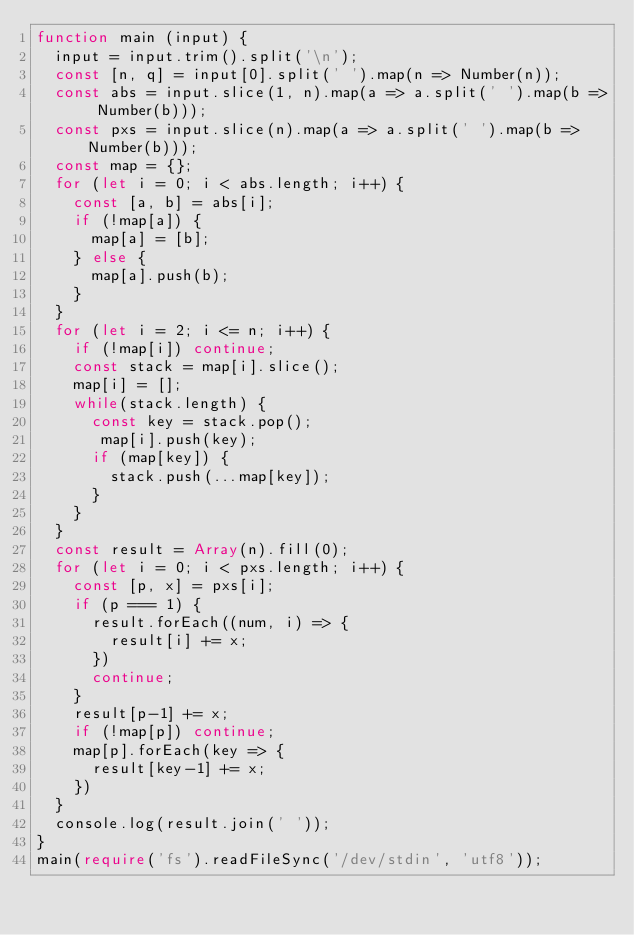Convert code to text. <code><loc_0><loc_0><loc_500><loc_500><_TypeScript_>function main (input) {
  input = input.trim().split('\n');
  const [n, q] = input[0].split(' ').map(n => Number(n));
  const abs = input.slice(1, n).map(a => a.split(' ').map(b => Number(b)));
  const pxs = input.slice(n).map(a => a.split(' ').map(b => Number(b)));
  const map = {};
  for (let i = 0; i < abs.length; i++) {
    const [a, b] = abs[i];
    if (!map[a]) {
      map[a] = [b];
    } else {
      map[a].push(b);
    }
  }
  for (let i = 2; i <= n; i++) {
    if (!map[i]) continue;
    const stack = map[i].slice();
    map[i] = [];
    while(stack.length) {
      const key = stack.pop();
       map[i].push(key);
      if (map[key]) {
        stack.push(...map[key]);
      }
    }
  }
  const result = Array(n).fill(0);
  for (let i = 0; i < pxs.length; i++) {
    const [p, x] = pxs[i];
    if (p === 1) {
      result.forEach((num, i) => {
        result[i] += x;
      })
      continue;
    }
    result[p-1] += x;
    if (!map[p]) continue;
    map[p].forEach(key => {
      result[key-1] += x;
    })
  }
  console.log(result.join(' '));
}
main(require('fs').readFileSync('/dev/stdin', 'utf8'));
</code> 